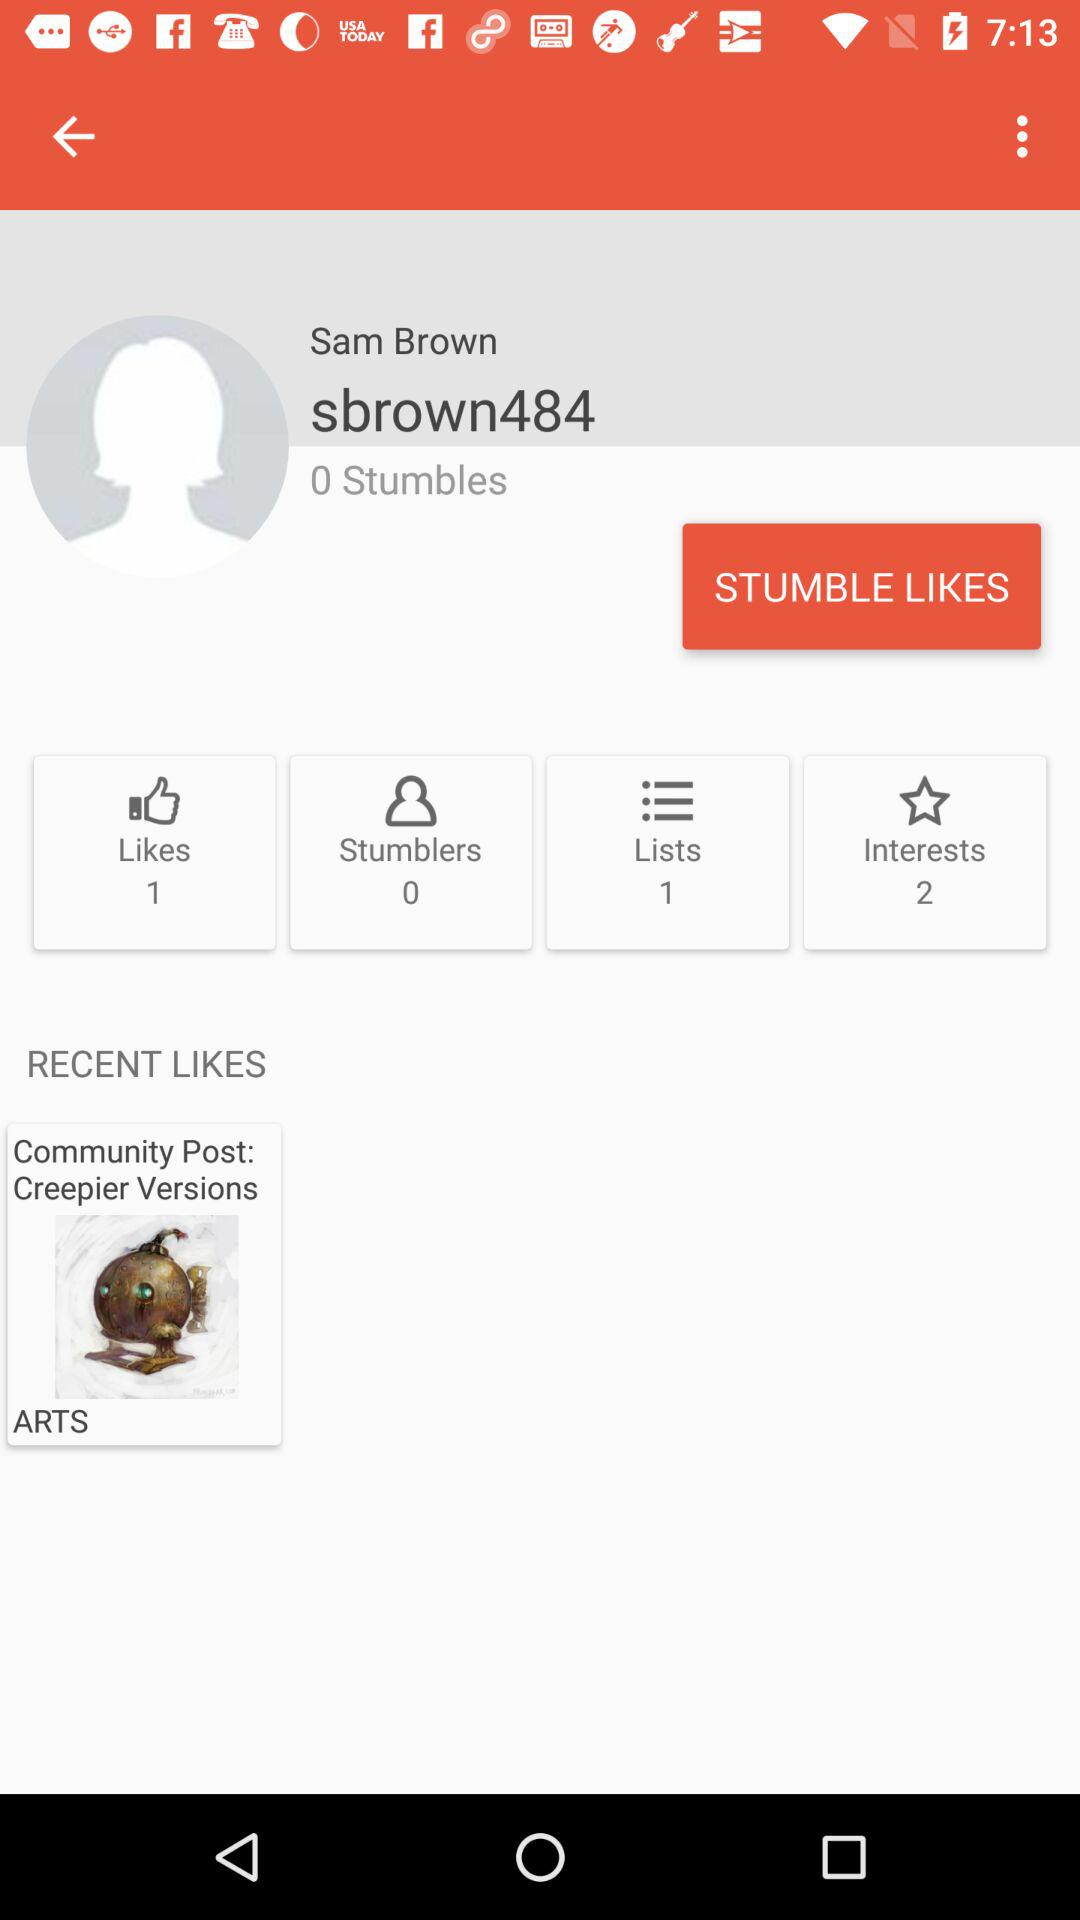What is the name of the user? The name of the user is Sam Brown. 